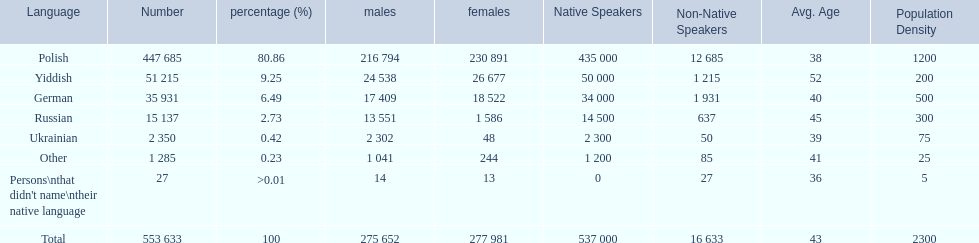What are the percentages of people? 80.86, 9.25, 6.49, 2.73, 0.42, 0.23, >0.01. Which language is .42%? Ukrainian. 